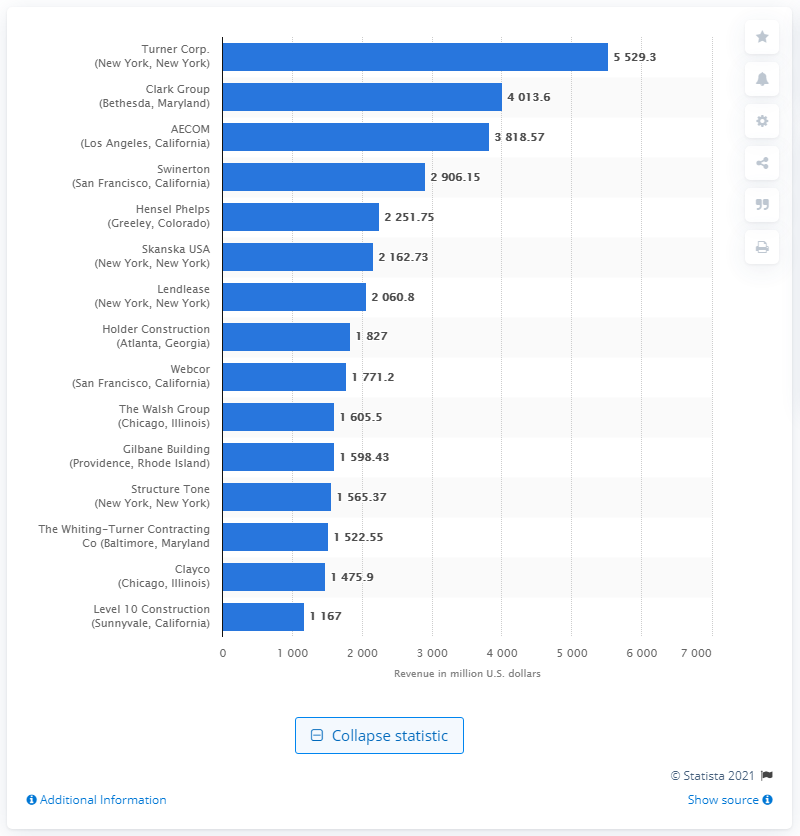Indicate a few pertinent items in this graphic. In 2017, the revenue generated from green design by Turner Corp. was $55,293.30. 